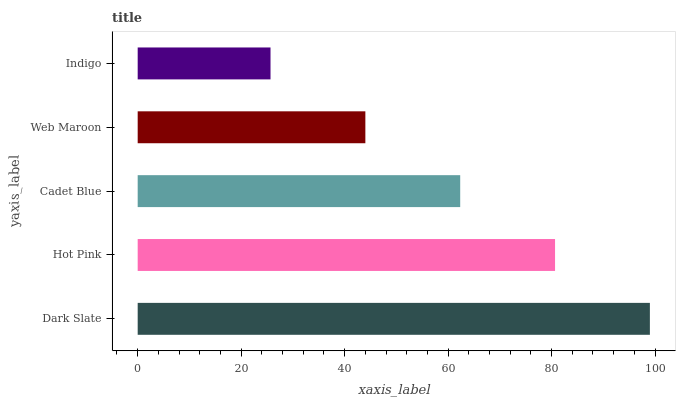Is Indigo the minimum?
Answer yes or no. Yes. Is Dark Slate the maximum?
Answer yes or no. Yes. Is Hot Pink the minimum?
Answer yes or no. No. Is Hot Pink the maximum?
Answer yes or no. No. Is Dark Slate greater than Hot Pink?
Answer yes or no. Yes. Is Hot Pink less than Dark Slate?
Answer yes or no. Yes. Is Hot Pink greater than Dark Slate?
Answer yes or no. No. Is Dark Slate less than Hot Pink?
Answer yes or no. No. Is Cadet Blue the high median?
Answer yes or no. Yes. Is Cadet Blue the low median?
Answer yes or no. Yes. Is Hot Pink the high median?
Answer yes or no. No. Is Dark Slate the low median?
Answer yes or no. No. 